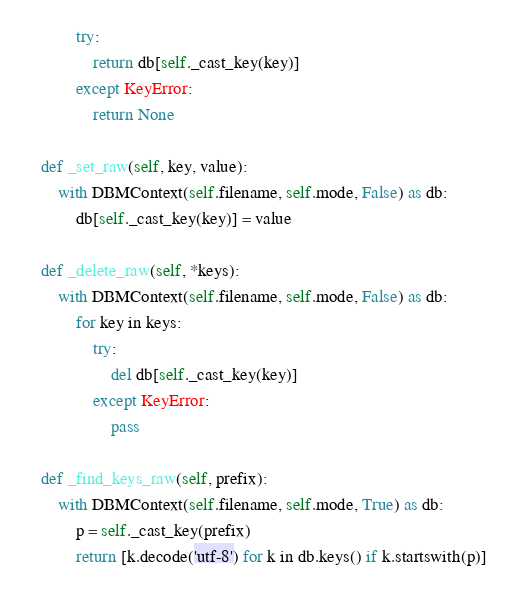Convert code to text. <code><loc_0><loc_0><loc_500><loc_500><_Python_>            try:
                return db[self._cast_key(key)]
            except KeyError:
                return None

    def _set_raw(self, key, value):
        with DBMContext(self.filename, self.mode, False) as db:
            db[self._cast_key(key)] = value

    def _delete_raw(self, *keys):
        with DBMContext(self.filename, self.mode, False) as db:
            for key in keys:
                try:
                    del db[self._cast_key(key)]
                except KeyError:
                    pass

    def _find_keys_raw(self, prefix):
        with DBMContext(self.filename, self.mode, True) as db:
            p = self._cast_key(prefix)
            return [k.decode('utf-8') for k in db.keys() if k.startswith(p)]
</code> 